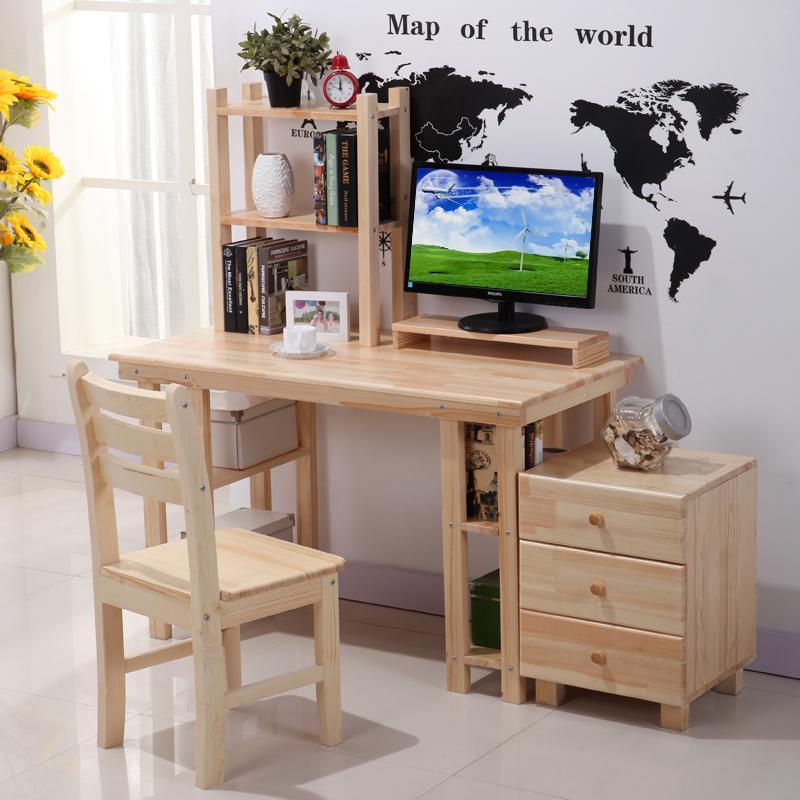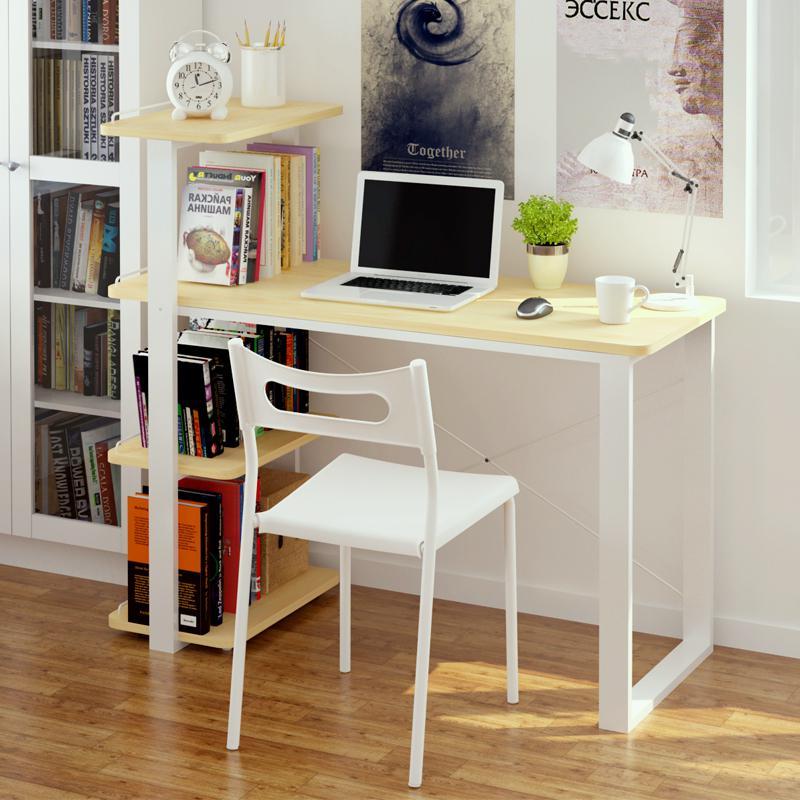The first image is the image on the left, the second image is the image on the right. For the images shown, is this caption "Both sides of the desk are actually book shelves." true? Answer yes or no. No. The first image is the image on the left, the second image is the image on the right. Examine the images to the left and right. Is the description "There is a total of 1 flower-less, green, leafy plant sitting to the right of a laptop screen." accurate? Answer yes or no. Yes. 